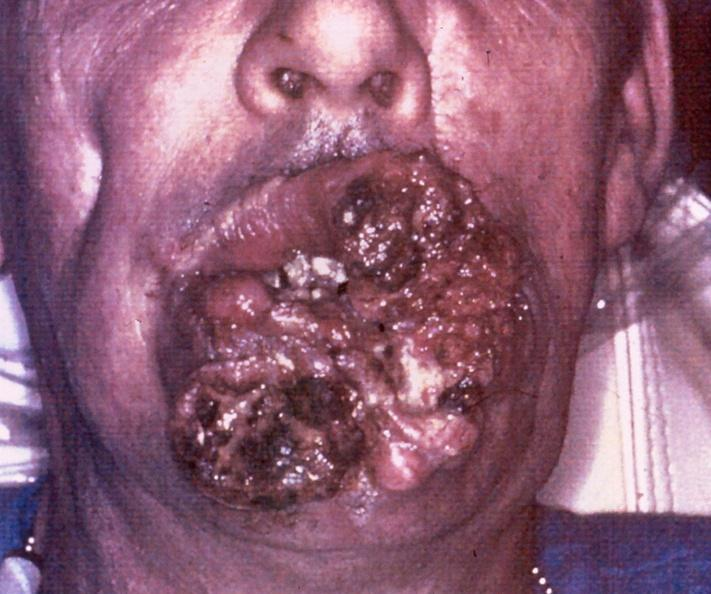where does this belong to?
Answer the question using a single word or phrase. Gastrointestinal system 